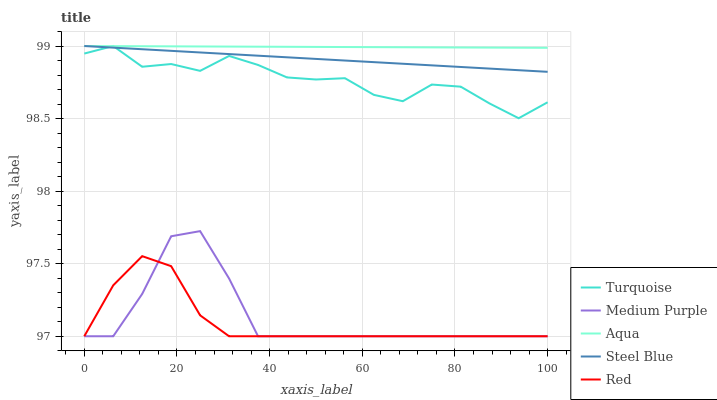Does Red have the minimum area under the curve?
Answer yes or no. Yes. Does Aqua have the maximum area under the curve?
Answer yes or no. Yes. Does Turquoise have the minimum area under the curve?
Answer yes or no. No. Does Turquoise have the maximum area under the curve?
Answer yes or no. No. Is Steel Blue the smoothest?
Answer yes or no. Yes. Is Turquoise the roughest?
Answer yes or no. Yes. Is Aqua the smoothest?
Answer yes or no. No. Is Aqua the roughest?
Answer yes or no. No. Does Medium Purple have the lowest value?
Answer yes or no. Yes. Does Turquoise have the lowest value?
Answer yes or no. No. Does Steel Blue have the highest value?
Answer yes or no. Yes. Does Red have the highest value?
Answer yes or no. No. Is Medium Purple less than Aqua?
Answer yes or no. Yes. Is Turquoise greater than Medium Purple?
Answer yes or no. Yes. Does Steel Blue intersect Aqua?
Answer yes or no. Yes. Is Steel Blue less than Aqua?
Answer yes or no. No. Is Steel Blue greater than Aqua?
Answer yes or no. No. Does Medium Purple intersect Aqua?
Answer yes or no. No. 